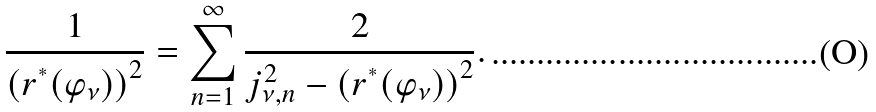<formula> <loc_0><loc_0><loc_500><loc_500>\frac { 1 } { \left ( r ^ { ^ { * } } ( \varphi _ { \nu } ) \right ) ^ { 2 } } = \sum _ { n = 1 } ^ { \infty } \frac { 2 } { j _ { \nu , n } ^ { 2 } - \left ( r ^ { ^ { * } } ( \varphi _ { \nu } ) \right ) ^ { 2 } } .</formula> 